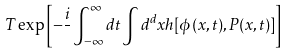Convert formula to latex. <formula><loc_0><loc_0><loc_500><loc_500>T \exp \left [ - \frac { i } { } \int ^ { \infty } _ { - \infty } d t \int d ^ { d } x h [ \phi ( x , t ) , P ( x , t ) ] \right ]</formula> 